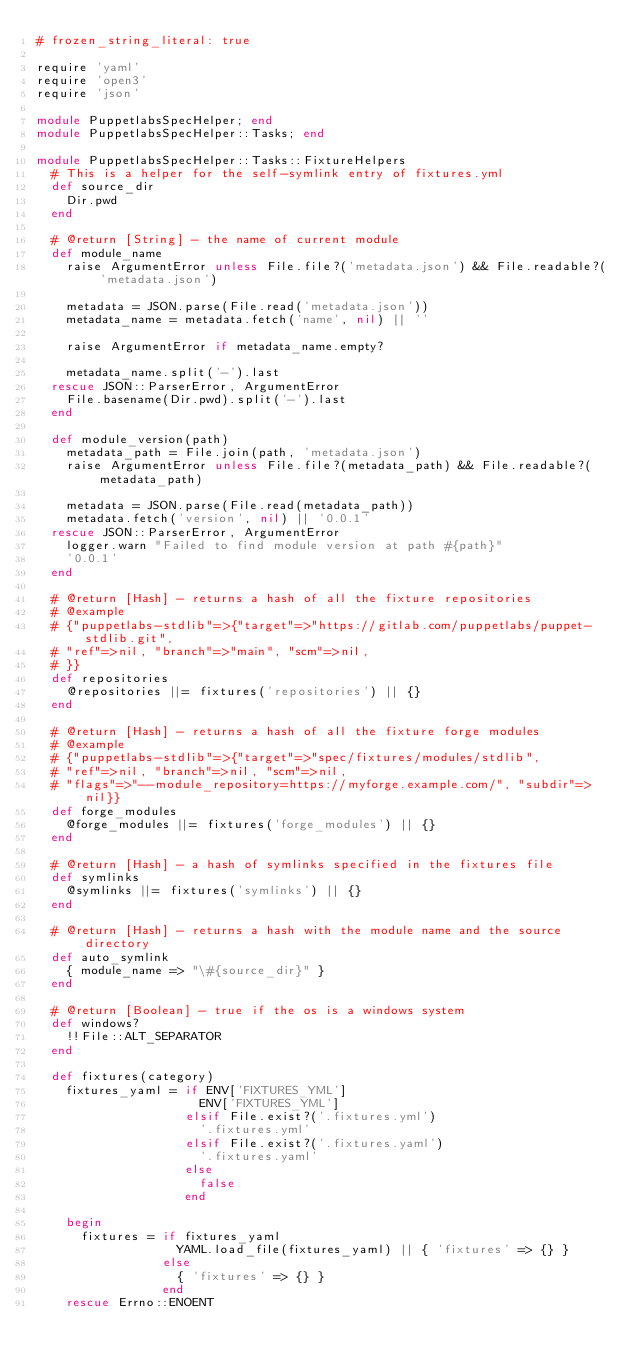Convert code to text. <code><loc_0><loc_0><loc_500><loc_500><_Ruby_># frozen_string_literal: true

require 'yaml'
require 'open3'
require 'json'

module PuppetlabsSpecHelper; end
module PuppetlabsSpecHelper::Tasks; end

module PuppetlabsSpecHelper::Tasks::FixtureHelpers
  # This is a helper for the self-symlink entry of fixtures.yml
  def source_dir
    Dir.pwd
  end

  # @return [String] - the name of current module
  def module_name
    raise ArgumentError unless File.file?('metadata.json') && File.readable?('metadata.json')

    metadata = JSON.parse(File.read('metadata.json'))
    metadata_name = metadata.fetch('name', nil) || ''

    raise ArgumentError if metadata_name.empty?

    metadata_name.split('-').last
  rescue JSON::ParserError, ArgumentError
    File.basename(Dir.pwd).split('-').last
  end

  def module_version(path)
    metadata_path = File.join(path, 'metadata.json')
    raise ArgumentError unless File.file?(metadata_path) && File.readable?(metadata_path)

    metadata = JSON.parse(File.read(metadata_path))
    metadata.fetch('version', nil) || '0.0.1'
  rescue JSON::ParserError, ArgumentError
    logger.warn "Failed to find module version at path #{path}"
    '0.0.1'
  end

  # @return [Hash] - returns a hash of all the fixture repositories
  # @example
  # {"puppetlabs-stdlib"=>{"target"=>"https://gitlab.com/puppetlabs/puppet-stdlib.git",
  # "ref"=>nil, "branch"=>"main", "scm"=>nil,
  # }}
  def repositories
    @repositories ||= fixtures('repositories') || {}
  end

  # @return [Hash] - returns a hash of all the fixture forge modules
  # @example
  # {"puppetlabs-stdlib"=>{"target"=>"spec/fixtures/modules/stdlib",
  # "ref"=>nil, "branch"=>nil, "scm"=>nil,
  # "flags"=>"--module_repository=https://myforge.example.com/", "subdir"=>nil}}
  def forge_modules
    @forge_modules ||= fixtures('forge_modules') || {}
  end

  # @return [Hash] - a hash of symlinks specified in the fixtures file
  def symlinks
    @symlinks ||= fixtures('symlinks') || {}
  end

  # @return [Hash] - returns a hash with the module name and the source directory
  def auto_symlink
    { module_name => "\#{source_dir}" }
  end

  # @return [Boolean] - true if the os is a windows system
  def windows?
    !!File::ALT_SEPARATOR
  end

  def fixtures(category)
    fixtures_yaml = if ENV['FIXTURES_YML']
                      ENV['FIXTURES_YML']
                    elsif File.exist?('.fixtures.yml')
                      '.fixtures.yml'
                    elsif File.exist?('.fixtures.yaml')
                      '.fixtures.yaml'
                    else
                      false
                    end

    begin
      fixtures = if fixtures_yaml
                   YAML.load_file(fixtures_yaml) || { 'fixtures' => {} }
                 else
                   { 'fixtures' => {} }
                 end
    rescue Errno::ENOENT</code> 